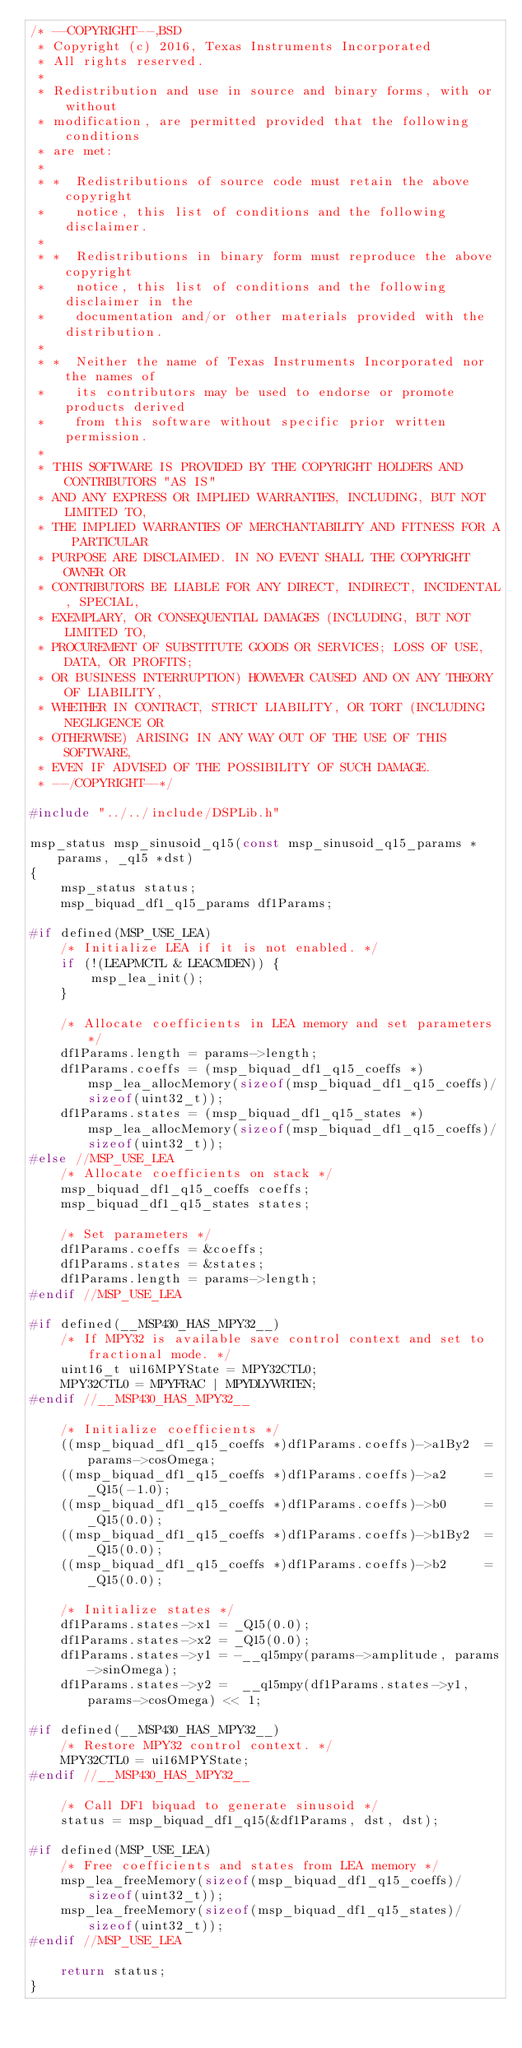Convert code to text. <code><loc_0><loc_0><loc_500><loc_500><_C_>/* --COPYRIGHT--,BSD
 * Copyright (c) 2016, Texas Instruments Incorporated
 * All rights reserved.
 *
 * Redistribution and use in source and binary forms, with or without
 * modification, are permitted provided that the following conditions
 * are met:
 *
 * *  Redistributions of source code must retain the above copyright
 *    notice, this list of conditions and the following disclaimer.
 *
 * *  Redistributions in binary form must reproduce the above copyright
 *    notice, this list of conditions and the following disclaimer in the
 *    documentation and/or other materials provided with the distribution.
 *
 * *  Neither the name of Texas Instruments Incorporated nor the names of
 *    its contributors may be used to endorse or promote products derived
 *    from this software without specific prior written permission.
 *
 * THIS SOFTWARE IS PROVIDED BY THE COPYRIGHT HOLDERS AND CONTRIBUTORS "AS IS"
 * AND ANY EXPRESS OR IMPLIED WARRANTIES, INCLUDING, BUT NOT LIMITED TO,
 * THE IMPLIED WARRANTIES OF MERCHANTABILITY AND FITNESS FOR A PARTICULAR
 * PURPOSE ARE DISCLAIMED. IN NO EVENT SHALL THE COPYRIGHT OWNER OR
 * CONTRIBUTORS BE LIABLE FOR ANY DIRECT, INDIRECT, INCIDENTAL, SPECIAL,
 * EXEMPLARY, OR CONSEQUENTIAL DAMAGES (INCLUDING, BUT NOT LIMITED TO,
 * PROCUREMENT OF SUBSTITUTE GOODS OR SERVICES; LOSS OF USE, DATA, OR PROFITS;
 * OR BUSINESS INTERRUPTION) HOWEVER CAUSED AND ON ANY THEORY OF LIABILITY,
 * WHETHER IN CONTRACT, STRICT LIABILITY, OR TORT (INCLUDING NEGLIGENCE OR
 * OTHERWISE) ARISING IN ANY WAY OUT OF THE USE OF THIS SOFTWARE,
 * EVEN IF ADVISED OF THE POSSIBILITY OF SUCH DAMAGE.
 * --/COPYRIGHT--*/

#include "../../include/DSPLib.h"

msp_status msp_sinusoid_q15(const msp_sinusoid_q15_params *params, _q15 *dst)
{
    msp_status status;
    msp_biquad_df1_q15_params df1Params;

#if defined(MSP_USE_LEA)
    /* Initialize LEA if it is not enabled. */
    if (!(LEAPMCTL & LEACMDEN)) {
        msp_lea_init();
    }

    /* Allocate coefficients in LEA memory and set parameters */
    df1Params.length = params->length;
    df1Params.coeffs = (msp_biquad_df1_q15_coeffs *)msp_lea_allocMemory(sizeof(msp_biquad_df1_q15_coeffs)/sizeof(uint32_t));
    df1Params.states = (msp_biquad_df1_q15_states *)msp_lea_allocMemory(sizeof(msp_biquad_df1_q15_coeffs)/sizeof(uint32_t));
#else //MSP_USE_LEA
    /* Allocate coefficients on stack */
    msp_biquad_df1_q15_coeffs coeffs;
    msp_biquad_df1_q15_states states;

    /* Set parameters */
    df1Params.coeffs = &coeffs;
    df1Params.states = &states;
    df1Params.length = params->length;
#endif //MSP_USE_LEA
    
#if defined(__MSP430_HAS_MPY32__)
    /* If MPY32 is available save control context and set to fractional mode. */
    uint16_t ui16MPYState = MPY32CTL0;
    MPY32CTL0 = MPYFRAC | MPYDLYWRTEN;
#endif //__MSP430_HAS_MPY32__

    /* Initialize coefficients */
    ((msp_biquad_df1_q15_coeffs *)df1Params.coeffs)->a1By2  = params->cosOmega;
    ((msp_biquad_df1_q15_coeffs *)df1Params.coeffs)->a2     = _Q15(-1.0);
    ((msp_biquad_df1_q15_coeffs *)df1Params.coeffs)->b0     = _Q15(0.0);
    ((msp_biquad_df1_q15_coeffs *)df1Params.coeffs)->b1By2  = _Q15(0.0);
    ((msp_biquad_df1_q15_coeffs *)df1Params.coeffs)->b2     = _Q15(0.0);

    /* Initialize states */
    df1Params.states->x1 = _Q15(0.0);
    df1Params.states->x2 = _Q15(0.0);
    df1Params.states->y1 = -__q15mpy(params->amplitude, params->sinOmega);
    df1Params.states->y2 =  __q15mpy(df1Params.states->y1, params->cosOmega) << 1;
    
#if defined(__MSP430_HAS_MPY32__)
    /* Restore MPY32 control context. */
    MPY32CTL0 = ui16MPYState;
#endif //__MSP430_HAS_MPY32__

    /* Call DF1 biquad to generate sinusoid */
    status = msp_biquad_df1_q15(&df1Params, dst, dst);
    
#if defined(MSP_USE_LEA)
    /* Free coefficients and states from LEA memory */
    msp_lea_freeMemory(sizeof(msp_biquad_df1_q15_coeffs)/sizeof(uint32_t));
    msp_lea_freeMemory(sizeof(msp_biquad_df1_q15_states)/sizeof(uint32_t));
#endif //MSP_USE_LEA

    return status;
}

</code> 